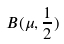Convert formula to latex. <formula><loc_0><loc_0><loc_500><loc_500>B ( \mu , \frac { 1 } { 2 } )</formula> 